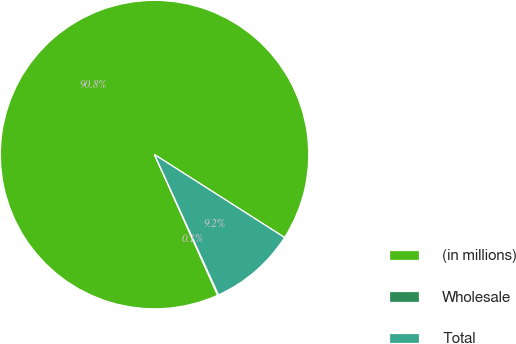Convert chart to OTSL. <chart><loc_0><loc_0><loc_500><loc_500><pie_chart><fcel>(in millions)<fcel>Wholesale<fcel>Total<nl><fcel>90.75%<fcel>0.09%<fcel>9.16%<nl></chart> 